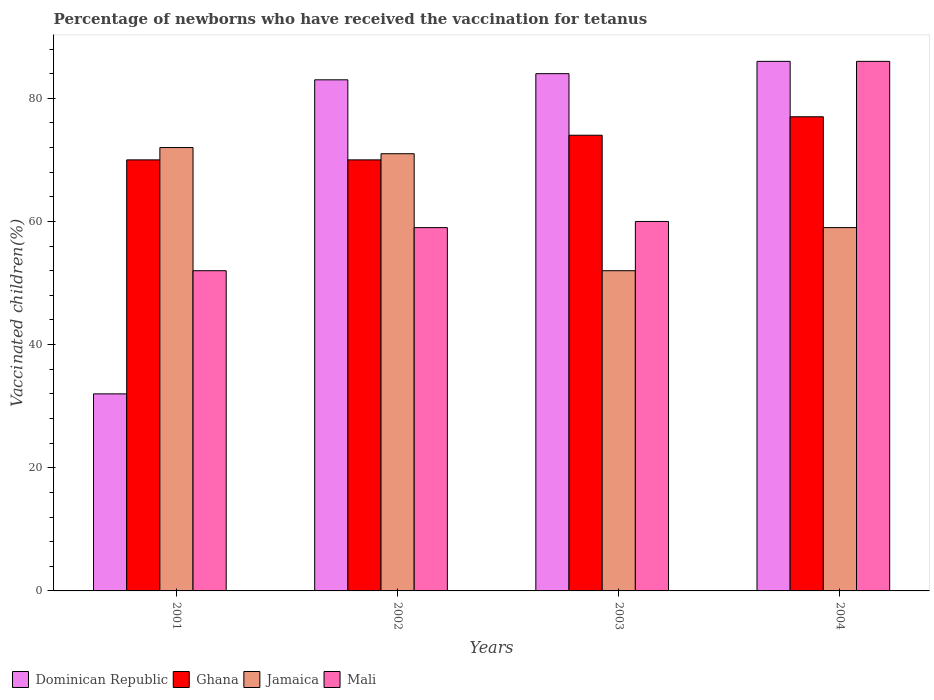How many bars are there on the 2nd tick from the left?
Your response must be concise. 4. How many bars are there on the 4th tick from the right?
Offer a very short reply. 4. In how many cases, is the number of bars for a given year not equal to the number of legend labels?
Your answer should be very brief. 0. Across all years, what is the minimum percentage of vaccinated children in Dominican Republic?
Provide a succinct answer. 32. In which year was the percentage of vaccinated children in Jamaica maximum?
Give a very brief answer. 2001. What is the total percentage of vaccinated children in Jamaica in the graph?
Keep it short and to the point. 254. What is the difference between the percentage of vaccinated children in Ghana in 2003 and that in 2004?
Provide a succinct answer. -3. What is the difference between the percentage of vaccinated children in Ghana in 2001 and the percentage of vaccinated children in Dominican Republic in 2002?
Keep it short and to the point. -13. What is the average percentage of vaccinated children in Dominican Republic per year?
Ensure brevity in your answer.  71.25. In how many years, is the percentage of vaccinated children in Dominican Republic greater than 44 %?
Your answer should be very brief. 3. What is the ratio of the percentage of vaccinated children in Dominican Republic in 2003 to that in 2004?
Your answer should be compact. 0.98. Is the percentage of vaccinated children in Dominican Republic in 2001 less than that in 2003?
Ensure brevity in your answer.  Yes. Is the difference between the percentage of vaccinated children in Dominican Republic in 2001 and 2004 greater than the difference between the percentage of vaccinated children in Mali in 2001 and 2004?
Ensure brevity in your answer.  No. What is the difference between the highest and the second highest percentage of vaccinated children in Ghana?
Your answer should be compact. 3. What is the difference between the highest and the lowest percentage of vaccinated children in Ghana?
Your answer should be very brief. 7. In how many years, is the percentage of vaccinated children in Dominican Republic greater than the average percentage of vaccinated children in Dominican Republic taken over all years?
Your response must be concise. 3. Is it the case that in every year, the sum of the percentage of vaccinated children in Ghana and percentage of vaccinated children in Mali is greater than the sum of percentage of vaccinated children in Jamaica and percentage of vaccinated children in Dominican Republic?
Offer a very short reply. No. What does the 4th bar from the left in 2001 represents?
Your response must be concise. Mali. What does the 4th bar from the right in 2001 represents?
Your answer should be compact. Dominican Republic. Is it the case that in every year, the sum of the percentage of vaccinated children in Dominican Republic and percentage of vaccinated children in Mali is greater than the percentage of vaccinated children in Ghana?
Ensure brevity in your answer.  Yes. Are all the bars in the graph horizontal?
Keep it short and to the point. No. Does the graph contain any zero values?
Provide a succinct answer. No. Does the graph contain grids?
Your answer should be very brief. No. Where does the legend appear in the graph?
Make the answer very short. Bottom left. How are the legend labels stacked?
Provide a succinct answer. Horizontal. What is the title of the graph?
Offer a very short reply. Percentage of newborns who have received the vaccination for tetanus. What is the label or title of the X-axis?
Offer a very short reply. Years. What is the label or title of the Y-axis?
Provide a short and direct response. Vaccinated children(%). What is the Vaccinated children(%) of Dominican Republic in 2001?
Keep it short and to the point. 32. What is the Vaccinated children(%) in Jamaica in 2001?
Provide a succinct answer. 72. What is the Vaccinated children(%) in Ghana in 2002?
Keep it short and to the point. 70. What is the Vaccinated children(%) in Jamaica in 2002?
Provide a short and direct response. 71. What is the Vaccinated children(%) in Jamaica in 2003?
Your answer should be very brief. 52. What is the Vaccinated children(%) of Mali in 2003?
Your response must be concise. 60. Across all years, what is the maximum Vaccinated children(%) in Ghana?
Offer a terse response. 77. Across all years, what is the maximum Vaccinated children(%) in Jamaica?
Provide a succinct answer. 72. Across all years, what is the maximum Vaccinated children(%) of Mali?
Ensure brevity in your answer.  86. Across all years, what is the minimum Vaccinated children(%) of Jamaica?
Offer a very short reply. 52. Across all years, what is the minimum Vaccinated children(%) in Mali?
Make the answer very short. 52. What is the total Vaccinated children(%) of Dominican Republic in the graph?
Keep it short and to the point. 285. What is the total Vaccinated children(%) in Ghana in the graph?
Provide a short and direct response. 291. What is the total Vaccinated children(%) in Jamaica in the graph?
Give a very brief answer. 254. What is the total Vaccinated children(%) in Mali in the graph?
Give a very brief answer. 257. What is the difference between the Vaccinated children(%) in Dominican Republic in 2001 and that in 2002?
Your response must be concise. -51. What is the difference between the Vaccinated children(%) in Ghana in 2001 and that in 2002?
Provide a short and direct response. 0. What is the difference between the Vaccinated children(%) in Jamaica in 2001 and that in 2002?
Offer a very short reply. 1. What is the difference between the Vaccinated children(%) in Mali in 2001 and that in 2002?
Keep it short and to the point. -7. What is the difference between the Vaccinated children(%) of Dominican Republic in 2001 and that in 2003?
Your answer should be compact. -52. What is the difference between the Vaccinated children(%) of Dominican Republic in 2001 and that in 2004?
Your answer should be compact. -54. What is the difference between the Vaccinated children(%) in Jamaica in 2001 and that in 2004?
Offer a terse response. 13. What is the difference between the Vaccinated children(%) in Mali in 2001 and that in 2004?
Your response must be concise. -34. What is the difference between the Vaccinated children(%) of Dominican Republic in 2002 and that in 2003?
Your answer should be very brief. -1. What is the difference between the Vaccinated children(%) in Ghana in 2002 and that in 2003?
Make the answer very short. -4. What is the difference between the Vaccinated children(%) of Mali in 2002 and that in 2003?
Make the answer very short. -1. What is the difference between the Vaccinated children(%) of Jamaica in 2002 and that in 2004?
Make the answer very short. 12. What is the difference between the Vaccinated children(%) of Ghana in 2003 and that in 2004?
Keep it short and to the point. -3. What is the difference between the Vaccinated children(%) of Jamaica in 2003 and that in 2004?
Your answer should be compact. -7. What is the difference between the Vaccinated children(%) of Mali in 2003 and that in 2004?
Give a very brief answer. -26. What is the difference between the Vaccinated children(%) of Dominican Republic in 2001 and the Vaccinated children(%) of Ghana in 2002?
Provide a succinct answer. -38. What is the difference between the Vaccinated children(%) of Dominican Republic in 2001 and the Vaccinated children(%) of Jamaica in 2002?
Provide a short and direct response. -39. What is the difference between the Vaccinated children(%) of Dominican Republic in 2001 and the Vaccinated children(%) of Mali in 2002?
Your response must be concise. -27. What is the difference between the Vaccinated children(%) of Ghana in 2001 and the Vaccinated children(%) of Mali in 2002?
Your response must be concise. 11. What is the difference between the Vaccinated children(%) in Jamaica in 2001 and the Vaccinated children(%) in Mali in 2002?
Give a very brief answer. 13. What is the difference between the Vaccinated children(%) of Dominican Republic in 2001 and the Vaccinated children(%) of Ghana in 2003?
Provide a short and direct response. -42. What is the difference between the Vaccinated children(%) of Dominican Republic in 2001 and the Vaccinated children(%) of Jamaica in 2003?
Give a very brief answer. -20. What is the difference between the Vaccinated children(%) in Ghana in 2001 and the Vaccinated children(%) in Jamaica in 2003?
Provide a short and direct response. 18. What is the difference between the Vaccinated children(%) of Jamaica in 2001 and the Vaccinated children(%) of Mali in 2003?
Offer a very short reply. 12. What is the difference between the Vaccinated children(%) of Dominican Republic in 2001 and the Vaccinated children(%) of Ghana in 2004?
Keep it short and to the point. -45. What is the difference between the Vaccinated children(%) in Dominican Republic in 2001 and the Vaccinated children(%) in Mali in 2004?
Give a very brief answer. -54. What is the difference between the Vaccinated children(%) of Dominican Republic in 2002 and the Vaccinated children(%) of Jamaica in 2003?
Your answer should be very brief. 31. What is the difference between the Vaccinated children(%) in Dominican Republic in 2002 and the Vaccinated children(%) in Mali in 2003?
Your response must be concise. 23. What is the difference between the Vaccinated children(%) of Ghana in 2002 and the Vaccinated children(%) of Jamaica in 2003?
Keep it short and to the point. 18. What is the difference between the Vaccinated children(%) of Ghana in 2002 and the Vaccinated children(%) of Mali in 2003?
Your answer should be very brief. 10. What is the difference between the Vaccinated children(%) of Dominican Republic in 2002 and the Vaccinated children(%) of Ghana in 2004?
Ensure brevity in your answer.  6. What is the difference between the Vaccinated children(%) of Ghana in 2002 and the Vaccinated children(%) of Jamaica in 2004?
Provide a succinct answer. 11. What is the difference between the Vaccinated children(%) of Dominican Republic in 2003 and the Vaccinated children(%) of Jamaica in 2004?
Provide a short and direct response. 25. What is the difference between the Vaccinated children(%) in Dominican Republic in 2003 and the Vaccinated children(%) in Mali in 2004?
Provide a short and direct response. -2. What is the difference between the Vaccinated children(%) in Ghana in 2003 and the Vaccinated children(%) in Jamaica in 2004?
Offer a terse response. 15. What is the difference between the Vaccinated children(%) in Ghana in 2003 and the Vaccinated children(%) in Mali in 2004?
Make the answer very short. -12. What is the difference between the Vaccinated children(%) in Jamaica in 2003 and the Vaccinated children(%) in Mali in 2004?
Keep it short and to the point. -34. What is the average Vaccinated children(%) in Dominican Republic per year?
Make the answer very short. 71.25. What is the average Vaccinated children(%) of Ghana per year?
Offer a very short reply. 72.75. What is the average Vaccinated children(%) in Jamaica per year?
Provide a succinct answer. 63.5. What is the average Vaccinated children(%) in Mali per year?
Give a very brief answer. 64.25. In the year 2001, what is the difference between the Vaccinated children(%) in Dominican Republic and Vaccinated children(%) in Ghana?
Give a very brief answer. -38. In the year 2001, what is the difference between the Vaccinated children(%) in Dominican Republic and Vaccinated children(%) in Mali?
Offer a terse response. -20. In the year 2001, what is the difference between the Vaccinated children(%) in Ghana and Vaccinated children(%) in Mali?
Give a very brief answer. 18. In the year 2001, what is the difference between the Vaccinated children(%) in Jamaica and Vaccinated children(%) in Mali?
Provide a short and direct response. 20. In the year 2002, what is the difference between the Vaccinated children(%) of Ghana and Vaccinated children(%) of Mali?
Provide a succinct answer. 11. In the year 2003, what is the difference between the Vaccinated children(%) of Dominican Republic and Vaccinated children(%) of Jamaica?
Ensure brevity in your answer.  32. In the year 2003, what is the difference between the Vaccinated children(%) of Dominican Republic and Vaccinated children(%) of Mali?
Offer a very short reply. 24. In the year 2003, what is the difference between the Vaccinated children(%) of Ghana and Vaccinated children(%) of Jamaica?
Your response must be concise. 22. In the year 2003, what is the difference between the Vaccinated children(%) of Ghana and Vaccinated children(%) of Mali?
Your response must be concise. 14. In the year 2004, what is the difference between the Vaccinated children(%) of Dominican Republic and Vaccinated children(%) of Ghana?
Offer a very short reply. 9. In the year 2004, what is the difference between the Vaccinated children(%) in Dominican Republic and Vaccinated children(%) in Jamaica?
Your response must be concise. 27. In the year 2004, what is the difference between the Vaccinated children(%) in Ghana and Vaccinated children(%) in Jamaica?
Offer a terse response. 18. In the year 2004, what is the difference between the Vaccinated children(%) of Ghana and Vaccinated children(%) of Mali?
Make the answer very short. -9. In the year 2004, what is the difference between the Vaccinated children(%) in Jamaica and Vaccinated children(%) in Mali?
Keep it short and to the point. -27. What is the ratio of the Vaccinated children(%) of Dominican Republic in 2001 to that in 2002?
Your answer should be very brief. 0.39. What is the ratio of the Vaccinated children(%) in Jamaica in 2001 to that in 2002?
Make the answer very short. 1.01. What is the ratio of the Vaccinated children(%) in Mali in 2001 to that in 2002?
Ensure brevity in your answer.  0.88. What is the ratio of the Vaccinated children(%) in Dominican Republic in 2001 to that in 2003?
Keep it short and to the point. 0.38. What is the ratio of the Vaccinated children(%) of Ghana in 2001 to that in 2003?
Offer a terse response. 0.95. What is the ratio of the Vaccinated children(%) in Jamaica in 2001 to that in 2003?
Ensure brevity in your answer.  1.38. What is the ratio of the Vaccinated children(%) in Mali in 2001 to that in 2003?
Provide a succinct answer. 0.87. What is the ratio of the Vaccinated children(%) in Dominican Republic in 2001 to that in 2004?
Provide a short and direct response. 0.37. What is the ratio of the Vaccinated children(%) of Ghana in 2001 to that in 2004?
Your answer should be very brief. 0.91. What is the ratio of the Vaccinated children(%) of Jamaica in 2001 to that in 2004?
Make the answer very short. 1.22. What is the ratio of the Vaccinated children(%) of Mali in 2001 to that in 2004?
Ensure brevity in your answer.  0.6. What is the ratio of the Vaccinated children(%) in Ghana in 2002 to that in 2003?
Keep it short and to the point. 0.95. What is the ratio of the Vaccinated children(%) of Jamaica in 2002 to that in 2003?
Offer a very short reply. 1.37. What is the ratio of the Vaccinated children(%) in Mali in 2002 to that in 2003?
Your response must be concise. 0.98. What is the ratio of the Vaccinated children(%) of Dominican Republic in 2002 to that in 2004?
Offer a very short reply. 0.97. What is the ratio of the Vaccinated children(%) of Ghana in 2002 to that in 2004?
Your answer should be very brief. 0.91. What is the ratio of the Vaccinated children(%) of Jamaica in 2002 to that in 2004?
Keep it short and to the point. 1.2. What is the ratio of the Vaccinated children(%) in Mali in 2002 to that in 2004?
Ensure brevity in your answer.  0.69. What is the ratio of the Vaccinated children(%) of Dominican Republic in 2003 to that in 2004?
Offer a terse response. 0.98. What is the ratio of the Vaccinated children(%) in Jamaica in 2003 to that in 2004?
Your answer should be very brief. 0.88. What is the ratio of the Vaccinated children(%) in Mali in 2003 to that in 2004?
Your answer should be compact. 0.7. What is the difference between the highest and the second highest Vaccinated children(%) in Jamaica?
Provide a succinct answer. 1. What is the difference between the highest and the lowest Vaccinated children(%) of Ghana?
Provide a short and direct response. 7. What is the difference between the highest and the lowest Vaccinated children(%) in Jamaica?
Give a very brief answer. 20. What is the difference between the highest and the lowest Vaccinated children(%) in Mali?
Offer a very short reply. 34. 